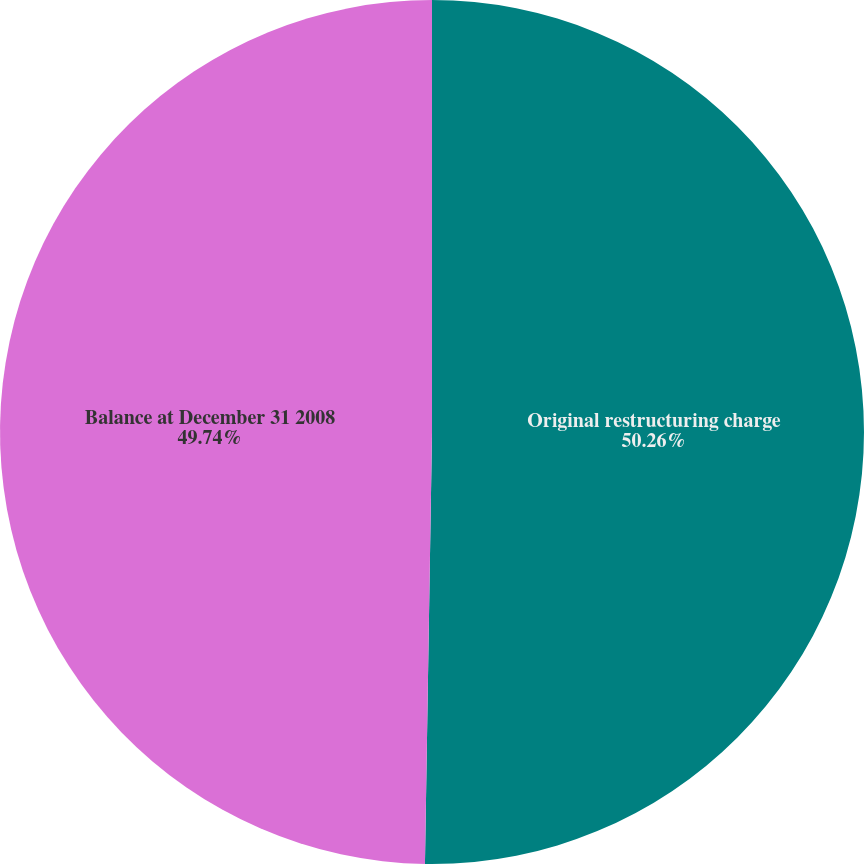<chart> <loc_0><loc_0><loc_500><loc_500><pie_chart><fcel>Original restructuring charge<fcel>Balance at December 31 2008<nl><fcel>50.26%<fcel>49.74%<nl></chart> 